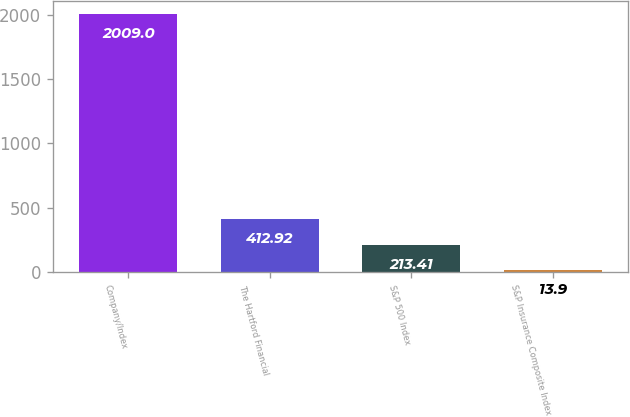Convert chart to OTSL. <chart><loc_0><loc_0><loc_500><loc_500><bar_chart><fcel>Company/Index<fcel>The Hartford Financial<fcel>S&P 500 Index<fcel>S&P Insurance Composite Index<nl><fcel>2009<fcel>412.92<fcel>213.41<fcel>13.9<nl></chart> 